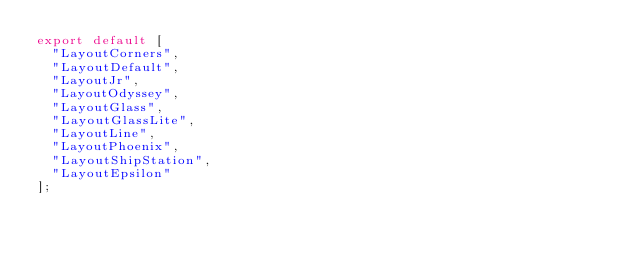Convert code to text. <code><loc_0><loc_0><loc_500><loc_500><_JavaScript_>export default [
  "LayoutCorners",
  "LayoutDefault",
  "LayoutJr",
  "LayoutOdyssey",
  "LayoutGlass",
  "LayoutGlassLite",
  "LayoutLine",
  "LayoutPhoenix",
  "LayoutShipStation",
  "LayoutEpsilon"
];
</code> 